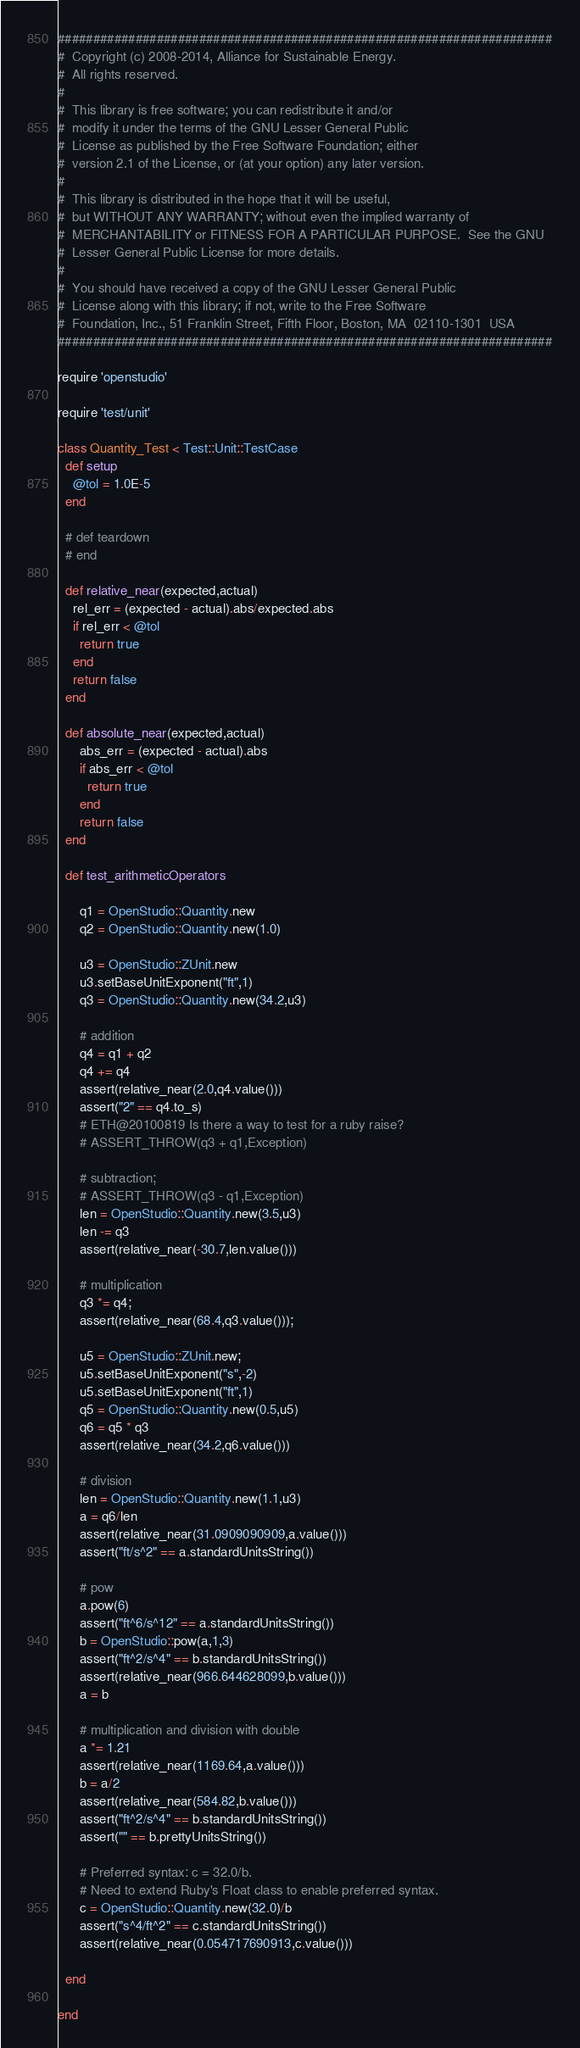Convert code to text. <code><loc_0><loc_0><loc_500><loc_500><_Ruby_>######################################################################
#  Copyright (c) 2008-2014, Alliance for Sustainable Energy.  
#  All rights reserved.
#  
#  This library is free software; you can redistribute it and/or
#  modify it under the terms of the GNU Lesser General Public
#  License as published by the Free Software Foundation; either
#  version 2.1 of the License, or (at your option) any later version.
#  
#  This library is distributed in the hope that it will be useful,
#  but WITHOUT ANY WARRANTY; without even the implied warranty of
#  MERCHANTABILITY or FITNESS FOR A PARTICULAR PURPOSE.  See the GNU
#  Lesser General Public License for more details.
#  
#  You should have received a copy of the GNU Lesser General Public
#  License along with this library; if not, write to the Free Software
#  Foundation, Inc., 51 Franklin Street, Fifth Floor, Boston, MA  02110-1301  USA
######################################################################

require 'openstudio'

require 'test/unit'

class Quantity_Test < Test::Unit::TestCase
  def setup
    @tol = 1.0E-5
  end

  # def teardown
  # end
  
  def relative_near(expected,actual)
    rel_err = (expected - actual).abs/expected.abs
    if rel_err < @tol
      return true
    end
    return false
  end
  
  def absolute_near(expected,actual)
      abs_err = (expected - actual).abs
      if abs_err < @tol
        return true
      end
      return false
  end
  
  def test_arithmeticOperators
  
      q1 = OpenStudio::Quantity.new
      q2 = OpenStudio::Quantity.new(1.0)
      
      u3 = OpenStudio::ZUnit.new
      u3.setBaseUnitExponent("ft",1)
      q3 = OpenStudio::Quantity.new(34.2,u3)
    
      # addition
      q4 = q1 + q2
      q4 += q4
      assert(relative_near(2.0,q4.value()))
      assert("2" == q4.to_s)
      # ETH@20100819 Is there a way to test for a ruby raise?
      # ASSERT_THROW(q3 + q1,Exception)
    
      # subtraction;
      # ASSERT_THROW(q3 - q1,Exception)
      len = OpenStudio::Quantity.new(3.5,u3)
      len -= q3
      assert(relative_near(-30.7,len.value()))
    
      # multiplication
      q3 *= q4;
      assert(relative_near(68.4,q3.value()));
    
      u5 = OpenStudio::ZUnit.new;
      u5.setBaseUnitExponent("s",-2)
      u5.setBaseUnitExponent("ft",1)
      q5 = OpenStudio::Quantity.new(0.5,u5)
      q6 = q5 * q3
      assert(relative_near(34.2,q6.value()))
    
      # division
      len = OpenStudio::Quantity.new(1.1,u3)
      a = q6/len
      assert(relative_near(31.0909090909,a.value()))
      assert("ft/s^2" == a.standardUnitsString())
    
      # pow
      a.pow(6)
      assert("ft^6/s^12" == a.standardUnitsString())
      b = OpenStudio::pow(a,1,3)
      assert("ft^2/s^4" == b.standardUnitsString())
      assert(relative_near(966.644628099,b.value()))
      a = b
    
      # multiplication and division with double
      a *= 1.21
      assert(relative_near(1169.64,a.value()))
      b = a/2
      assert(relative_near(584.82,b.value()))
      assert("ft^2/s^4" == b.standardUnitsString())
      assert("" == b.prettyUnitsString())
    
      # Preferred syntax: c = 32.0/b.
      # Need to extend Ruby's Float class to enable preferred syntax.
      c = OpenStudio::Quantity.new(32.0)/b
      assert("s^4/ft^2" == c.standardUnitsString())
      assert(relative_near(0.054717690913,c.value()))
    
  end
  
end</code> 